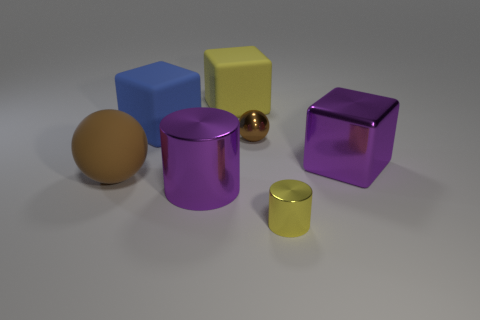Subtract all large rubber blocks. How many blocks are left? 1 Add 1 big yellow objects. How many objects exist? 8 Add 7 large purple cylinders. How many large purple cylinders are left? 8 Add 7 tiny things. How many tiny things exist? 9 Subtract 0 cyan balls. How many objects are left? 7 Subtract all cubes. How many objects are left? 4 Subtract all brown cubes. Subtract all yellow cylinders. How many cubes are left? 3 Subtract all large red shiny spheres. Subtract all large metallic cylinders. How many objects are left? 6 